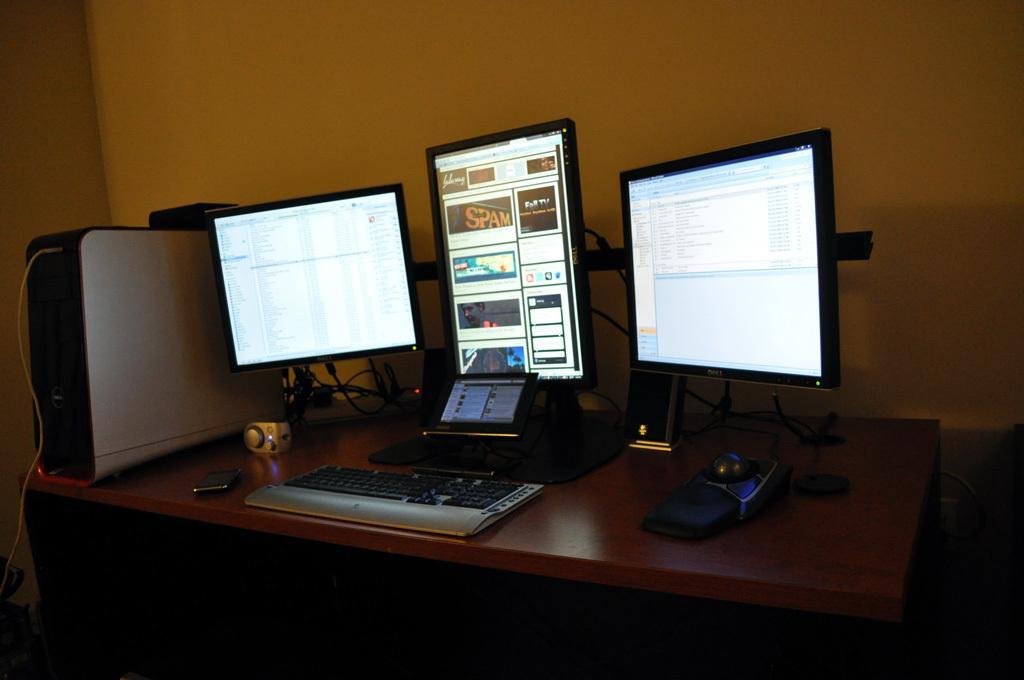In one or two sentences, can you explain what this image depicts? There is a table. There is a computer system,CPU,mobile phone,wire and keyboard on a table. We can see in background wall. 